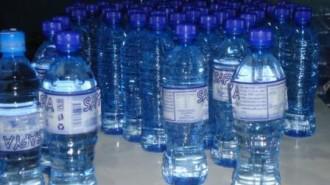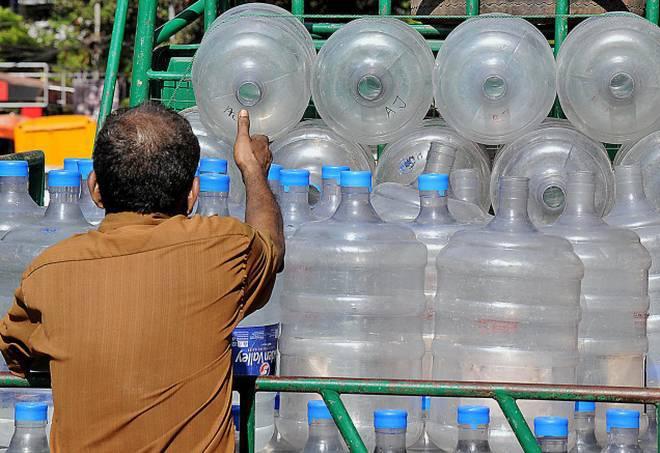The first image is the image on the left, the second image is the image on the right. Examine the images to the left and right. Is the description "The left and right image contains the same number of containers filled with water." accurate? Answer yes or no. No. The first image is the image on the left, the second image is the image on the right. For the images shown, is this caption "The right and left images include the same number of water containers." true? Answer yes or no. No. 